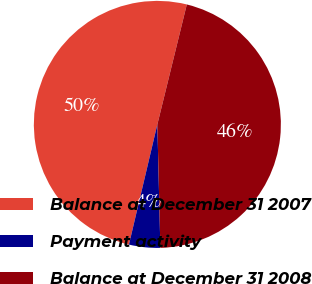<chart> <loc_0><loc_0><loc_500><loc_500><pie_chart><fcel>Balance at December 31 2007<fcel>Payment activity<fcel>Balance at December 31 2008<nl><fcel>50.14%<fcel>4.08%<fcel>45.78%<nl></chart> 